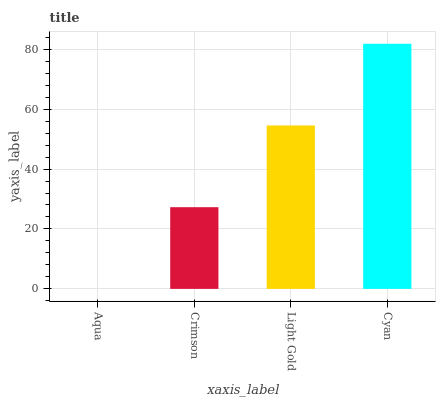Is Crimson the minimum?
Answer yes or no. No. Is Crimson the maximum?
Answer yes or no. No. Is Crimson greater than Aqua?
Answer yes or no. Yes. Is Aqua less than Crimson?
Answer yes or no. Yes. Is Aqua greater than Crimson?
Answer yes or no. No. Is Crimson less than Aqua?
Answer yes or no. No. Is Light Gold the high median?
Answer yes or no. Yes. Is Crimson the low median?
Answer yes or no. Yes. Is Aqua the high median?
Answer yes or no. No. Is Light Gold the low median?
Answer yes or no. No. 